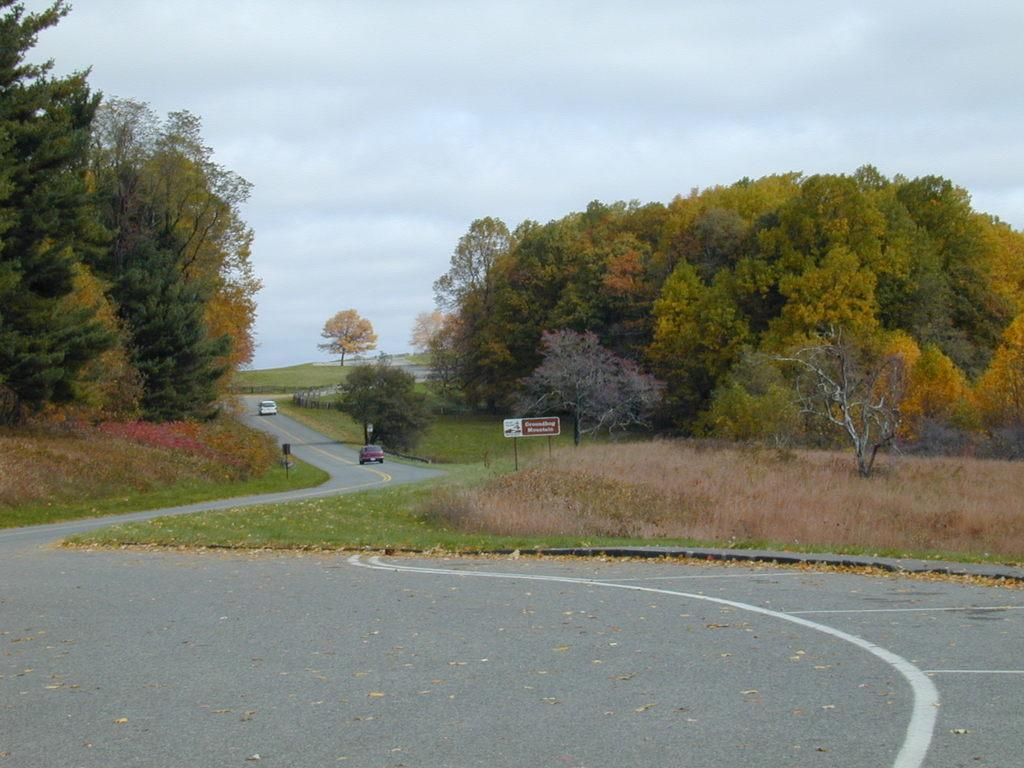What type of natural elements can be seen in the image? Dried leaves, grass, and trees are visible in the image. What man-made objects can be seen in the image? Cars on the road and a name board are visible in the image. What is the condition of the sky in the background of the image? The sky with clouds is visible in the background of the image. Can you describe the other objects present in the image? There are other objects in the image, but their specific details are not mentioned in the provided facts. How many rabbits can be seen playing with bait in the image? There are no rabbits or bait present in the image. What is the wish of the person standing near the name board in the image? There is no person standing near the name board in the image, and therefore no wish can be attributed to them. 